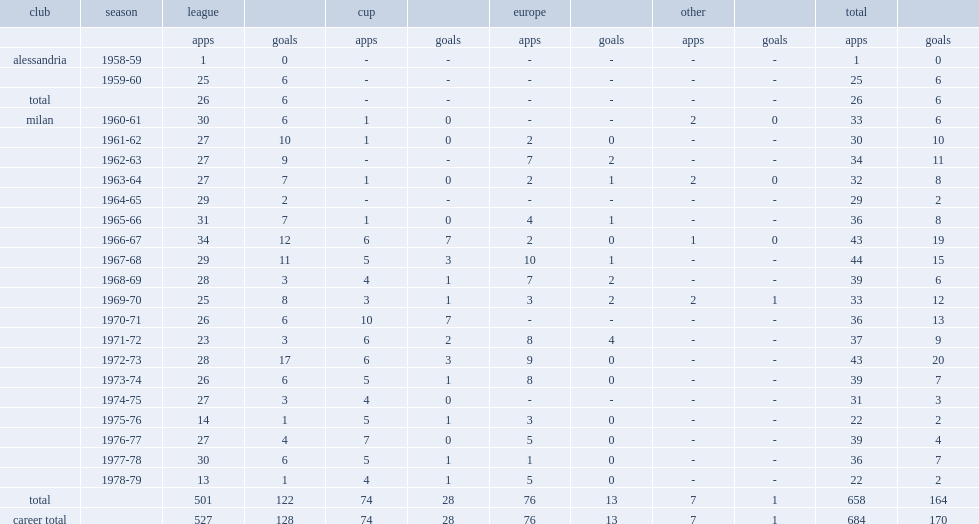How many league goals did rivera score for milan totally? 122.0. 